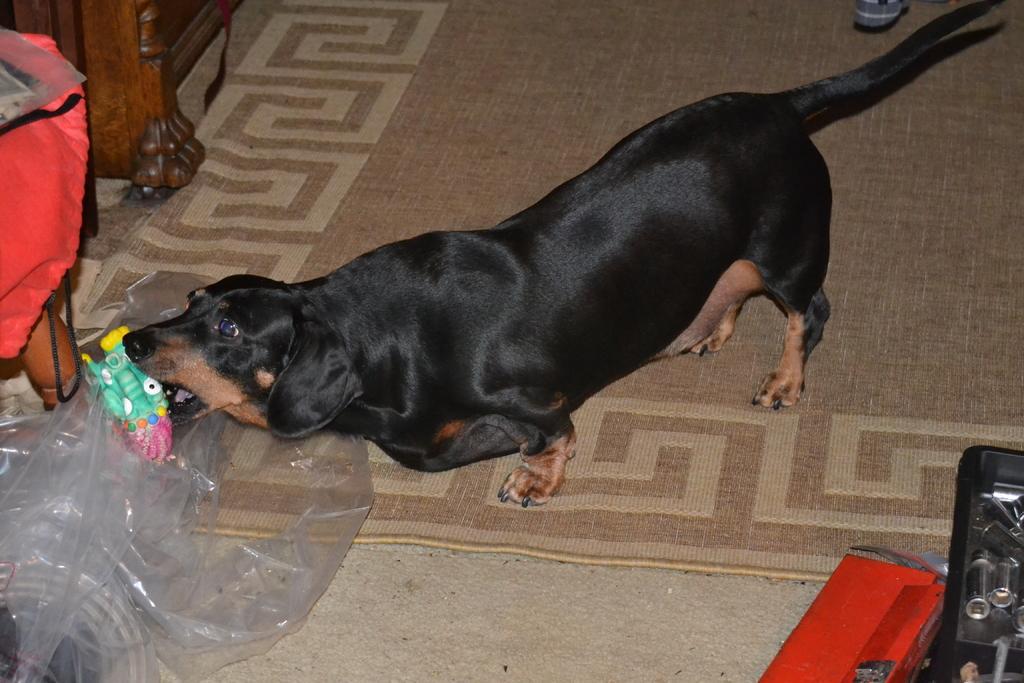Describe this image in one or two sentences. In this image I can see a black dog on the floor. On the left side I can see a polythene cover. 